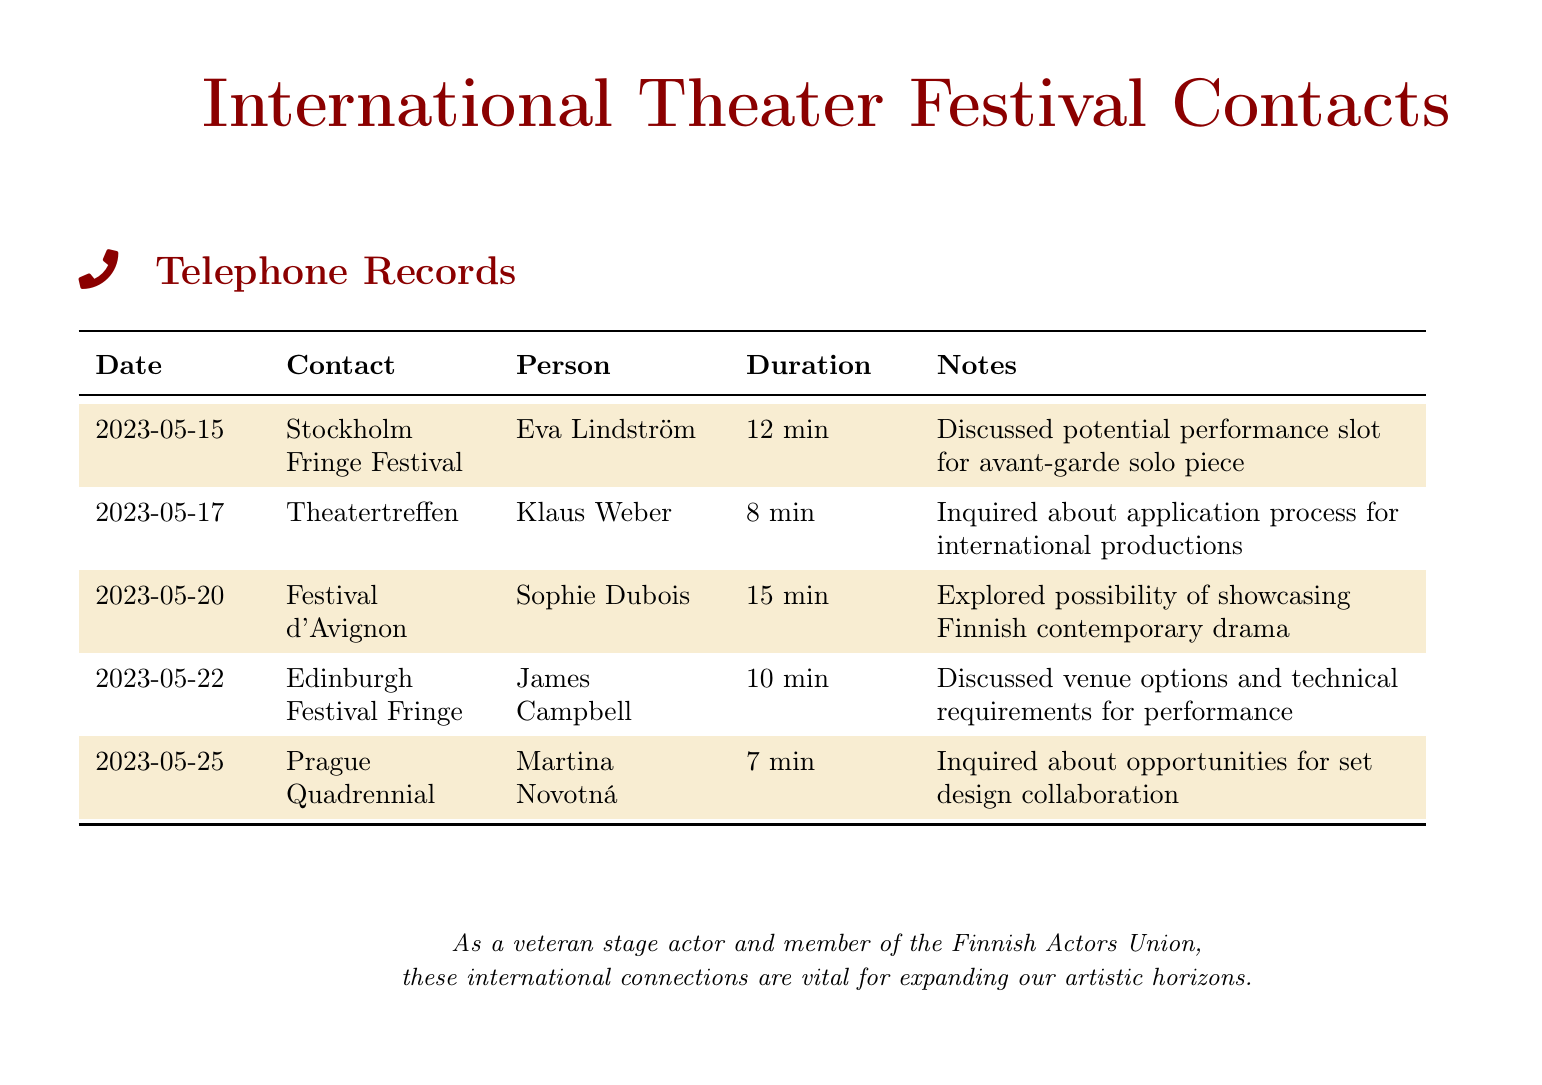What was the duration of the call with Eva Lindström? The duration of the call with Eva Lindström was specifically noted in the document as 12 minutes.
Answer: 12 min Who did you speak with regarding the Prague Quadrennial? The document lists Martina Novotná as the contact person for the Prague Quadrennial.
Answer: Martina Novotná On which date was the call made to the Festival d'Avignon? According to the document, the call to the Festival d'Avignon took place on May 20, 2023.
Answer: 2023-05-20 What was discussed during the call with Klaus Weber? The call with Klaus Weber involved inquiring about the application process for international productions.
Answer: Application process Which festival is associated with James Campbell? The document indicates that James Campbell is associated with the Edinburgh Festival Fringe.
Answer: Edinburgh Festival Fringe How many minutes was the call about opportunities for set design collaboration? The call concerning set design collaboration was noted to have a duration of 7 minutes.
Answer: 7 min What type of performance was discussed with Eva Lindström? The document mentions that an avant-garde solo piece was discussed for performance.
Answer: Avant-garde solo piece Which festival is focused on showcasing Finnish contemporary drama? The Festival d'Avignon is indicated as the one where showcasing Finnish contemporary drama was explored.
Answer: Festival d'Avignon 